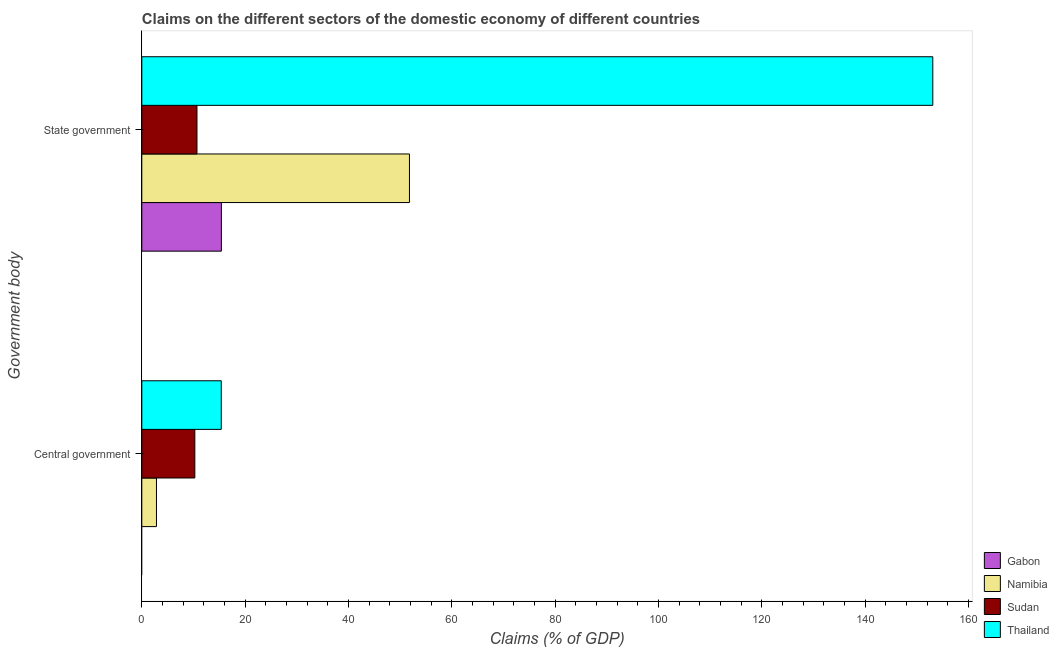How many different coloured bars are there?
Ensure brevity in your answer.  4. How many groups of bars are there?
Keep it short and to the point. 2. What is the label of the 2nd group of bars from the top?
Your answer should be very brief. Central government. What is the claims on central government in Namibia?
Offer a terse response. 2.84. Across all countries, what is the maximum claims on central government?
Offer a terse response. 15.38. In which country was the claims on state government maximum?
Offer a terse response. Thailand. What is the total claims on state government in the graph?
Your answer should be compact. 230.99. What is the difference between the claims on state government in Sudan and that in Gabon?
Your response must be concise. -4.73. What is the difference between the claims on central government in Thailand and the claims on state government in Namibia?
Offer a terse response. -36.42. What is the average claims on state government per country?
Your response must be concise. 57.75. What is the difference between the claims on central government and claims on state government in Thailand?
Your answer should be very brief. -137.72. In how many countries, is the claims on central government greater than 8 %?
Keep it short and to the point. 2. What is the ratio of the claims on central government in Namibia to that in Thailand?
Your answer should be compact. 0.18. How many bars are there?
Provide a short and direct response. 7. How many countries are there in the graph?
Your answer should be compact. 4. Are the values on the major ticks of X-axis written in scientific E-notation?
Your answer should be very brief. No. Does the graph contain grids?
Your answer should be compact. No. Where does the legend appear in the graph?
Make the answer very short. Bottom right. How many legend labels are there?
Offer a terse response. 4. How are the legend labels stacked?
Your answer should be very brief. Vertical. What is the title of the graph?
Provide a succinct answer. Claims on the different sectors of the domestic economy of different countries. Does "Honduras" appear as one of the legend labels in the graph?
Offer a terse response. No. What is the label or title of the X-axis?
Make the answer very short. Claims (% of GDP). What is the label or title of the Y-axis?
Offer a very short reply. Government body. What is the Claims (% of GDP) in Namibia in Central government?
Provide a short and direct response. 2.84. What is the Claims (% of GDP) in Sudan in Central government?
Offer a very short reply. 10.26. What is the Claims (% of GDP) in Thailand in Central government?
Provide a short and direct response. 15.38. What is the Claims (% of GDP) of Gabon in State government?
Ensure brevity in your answer.  15.4. What is the Claims (% of GDP) of Namibia in State government?
Your answer should be very brief. 51.81. What is the Claims (% of GDP) in Sudan in State government?
Give a very brief answer. 10.68. What is the Claims (% of GDP) of Thailand in State government?
Your answer should be compact. 153.1. Across all Government body, what is the maximum Claims (% of GDP) of Gabon?
Keep it short and to the point. 15.4. Across all Government body, what is the maximum Claims (% of GDP) of Namibia?
Your response must be concise. 51.81. Across all Government body, what is the maximum Claims (% of GDP) in Sudan?
Keep it short and to the point. 10.68. Across all Government body, what is the maximum Claims (% of GDP) in Thailand?
Offer a very short reply. 153.1. Across all Government body, what is the minimum Claims (% of GDP) of Gabon?
Make the answer very short. 0. Across all Government body, what is the minimum Claims (% of GDP) of Namibia?
Give a very brief answer. 2.84. Across all Government body, what is the minimum Claims (% of GDP) of Sudan?
Keep it short and to the point. 10.26. Across all Government body, what is the minimum Claims (% of GDP) in Thailand?
Keep it short and to the point. 15.38. What is the total Claims (% of GDP) in Gabon in the graph?
Your response must be concise. 15.4. What is the total Claims (% of GDP) of Namibia in the graph?
Offer a very short reply. 54.64. What is the total Claims (% of GDP) in Sudan in the graph?
Give a very brief answer. 20.94. What is the total Claims (% of GDP) in Thailand in the graph?
Offer a very short reply. 168.48. What is the difference between the Claims (% of GDP) in Namibia in Central government and that in State government?
Give a very brief answer. -48.97. What is the difference between the Claims (% of GDP) in Sudan in Central government and that in State government?
Offer a very short reply. -0.41. What is the difference between the Claims (% of GDP) of Thailand in Central government and that in State government?
Provide a succinct answer. -137.72. What is the difference between the Claims (% of GDP) of Namibia in Central government and the Claims (% of GDP) of Sudan in State government?
Make the answer very short. -7.84. What is the difference between the Claims (% of GDP) in Namibia in Central government and the Claims (% of GDP) in Thailand in State government?
Make the answer very short. -150.26. What is the difference between the Claims (% of GDP) of Sudan in Central government and the Claims (% of GDP) of Thailand in State government?
Your answer should be very brief. -142.84. What is the average Claims (% of GDP) of Gabon per Government body?
Your answer should be very brief. 7.7. What is the average Claims (% of GDP) of Namibia per Government body?
Provide a succinct answer. 27.32. What is the average Claims (% of GDP) in Sudan per Government body?
Your answer should be very brief. 10.47. What is the average Claims (% of GDP) in Thailand per Government body?
Offer a very short reply. 84.24. What is the difference between the Claims (% of GDP) in Namibia and Claims (% of GDP) in Sudan in Central government?
Give a very brief answer. -7.42. What is the difference between the Claims (% of GDP) of Namibia and Claims (% of GDP) of Thailand in Central government?
Keep it short and to the point. -12.54. What is the difference between the Claims (% of GDP) in Sudan and Claims (% of GDP) in Thailand in Central government?
Your answer should be very brief. -5.12. What is the difference between the Claims (% of GDP) in Gabon and Claims (% of GDP) in Namibia in State government?
Your answer should be very brief. -36.4. What is the difference between the Claims (% of GDP) in Gabon and Claims (% of GDP) in Sudan in State government?
Ensure brevity in your answer.  4.73. What is the difference between the Claims (% of GDP) of Gabon and Claims (% of GDP) of Thailand in State government?
Provide a short and direct response. -137.7. What is the difference between the Claims (% of GDP) in Namibia and Claims (% of GDP) in Sudan in State government?
Your answer should be compact. 41.13. What is the difference between the Claims (% of GDP) in Namibia and Claims (% of GDP) in Thailand in State government?
Ensure brevity in your answer.  -101.29. What is the difference between the Claims (% of GDP) in Sudan and Claims (% of GDP) in Thailand in State government?
Provide a short and direct response. -142.42. What is the ratio of the Claims (% of GDP) of Namibia in Central government to that in State government?
Your answer should be very brief. 0.05. What is the ratio of the Claims (% of GDP) of Sudan in Central government to that in State government?
Provide a succinct answer. 0.96. What is the ratio of the Claims (% of GDP) in Thailand in Central government to that in State government?
Keep it short and to the point. 0.1. What is the difference between the highest and the second highest Claims (% of GDP) of Namibia?
Your answer should be compact. 48.97. What is the difference between the highest and the second highest Claims (% of GDP) in Sudan?
Offer a terse response. 0.41. What is the difference between the highest and the second highest Claims (% of GDP) in Thailand?
Keep it short and to the point. 137.72. What is the difference between the highest and the lowest Claims (% of GDP) in Gabon?
Ensure brevity in your answer.  15.4. What is the difference between the highest and the lowest Claims (% of GDP) in Namibia?
Keep it short and to the point. 48.97. What is the difference between the highest and the lowest Claims (% of GDP) in Sudan?
Ensure brevity in your answer.  0.41. What is the difference between the highest and the lowest Claims (% of GDP) of Thailand?
Your response must be concise. 137.72. 